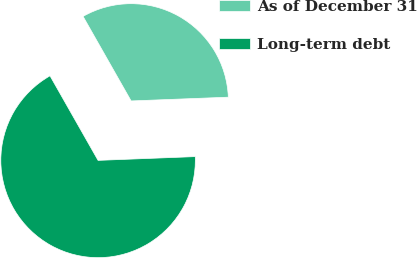<chart> <loc_0><loc_0><loc_500><loc_500><pie_chart><fcel>As of December 31<fcel>Long-term debt<nl><fcel>32.61%<fcel>67.39%<nl></chart> 